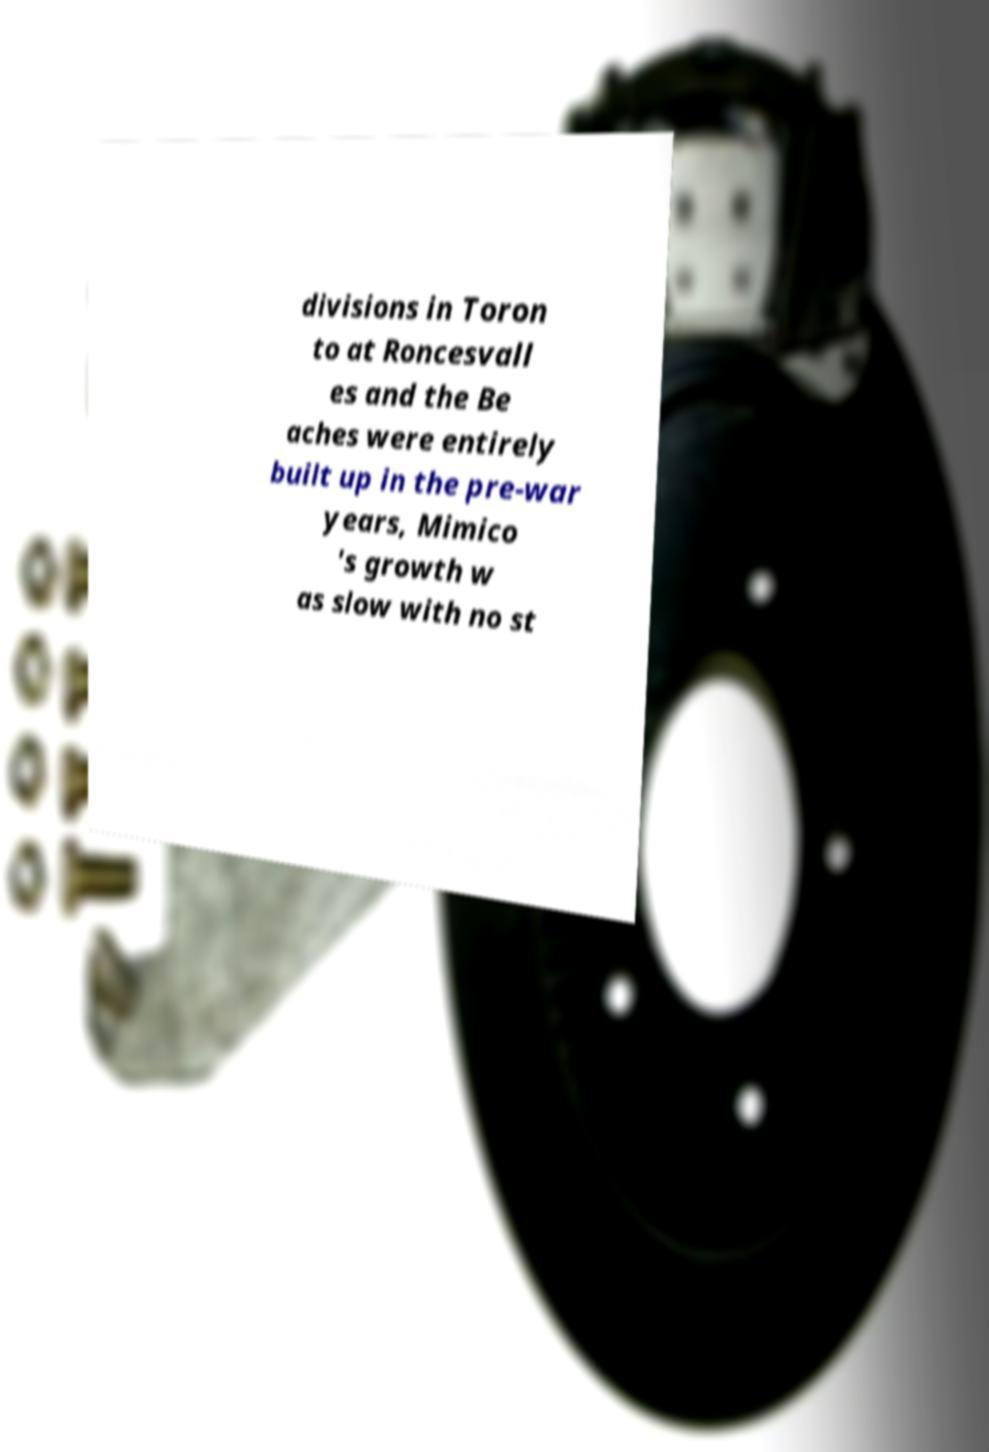I need the written content from this picture converted into text. Can you do that? divisions in Toron to at Roncesvall es and the Be aches were entirely built up in the pre-war years, Mimico 's growth w as slow with no st 